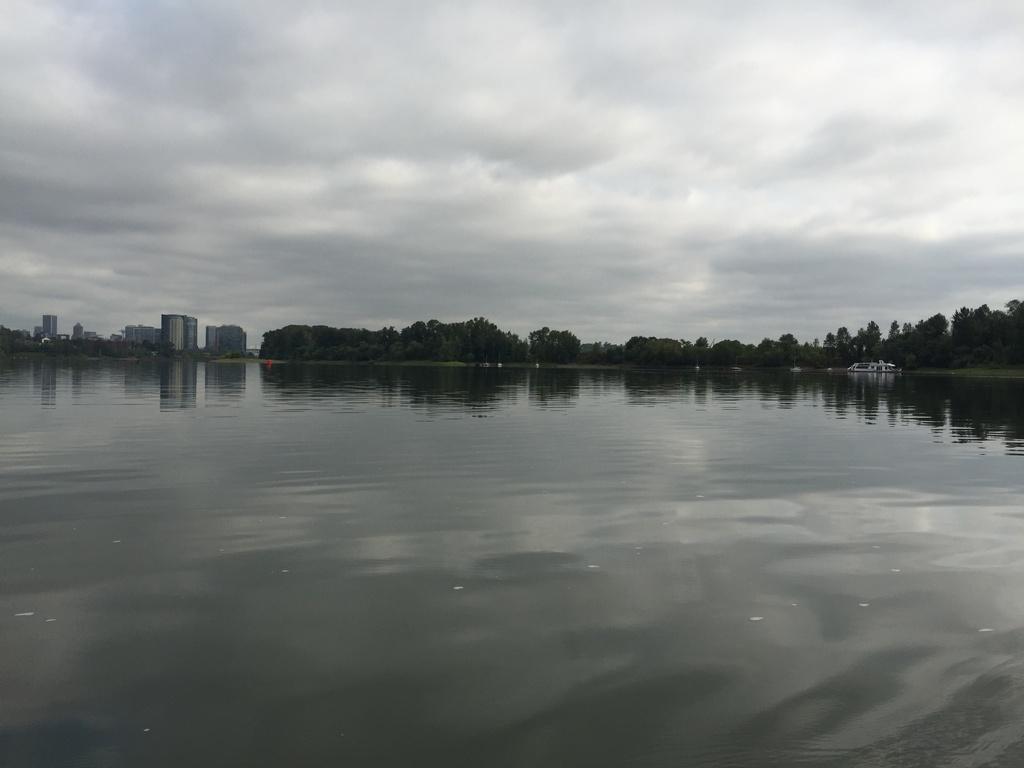Can you describe this image briefly? In the picture we can see the water surface and far away from it, we can see the trees and beside it, we can see some buildings and in the background we can see the sky with clouds. 